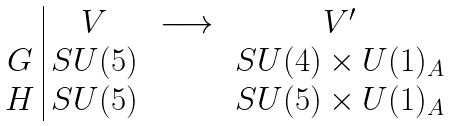<formula> <loc_0><loc_0><loc_500><loc_500>\begin{array} { c | c c c } & V & \, \longrightarrow \, & V ^ { \prime } \\ G & S U ( 5 ) & & S U ( 4 ) \times U ( 1 ) _ { A } \\ H & S U ( 5 ) & & S U ( 5 ) \times U ( 1 ) _ { A } \end{array}</formula> 